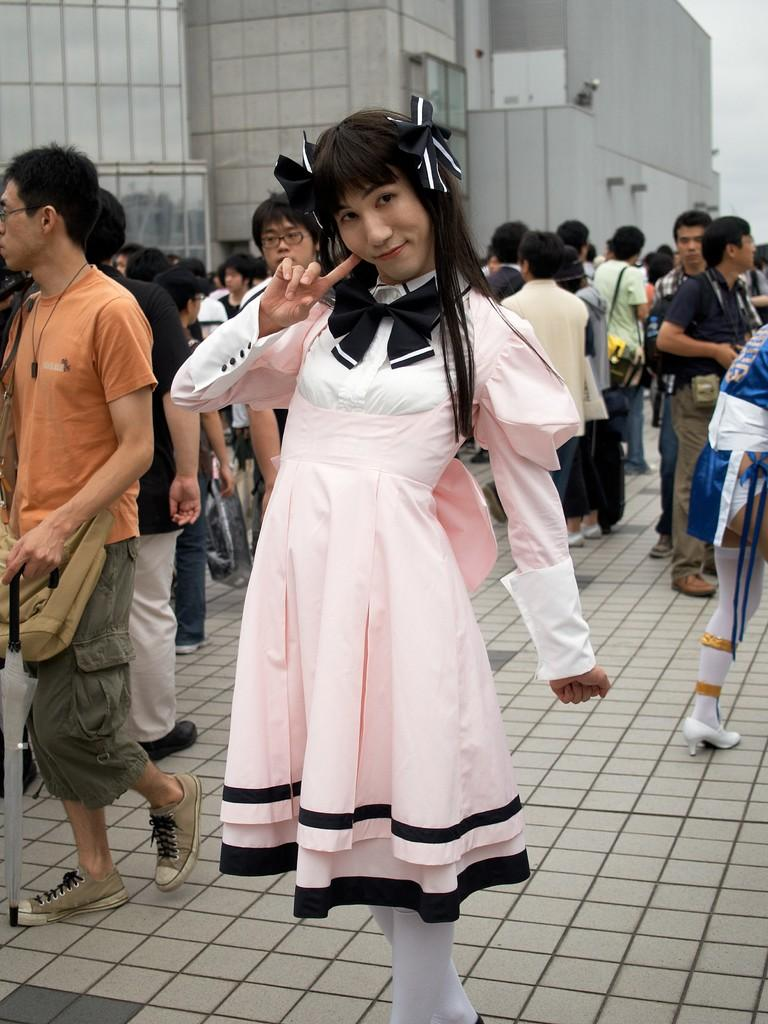How many people are in the image? There are many people in the foreground of the image. What can be seen in the background of the image? There are buildings visible in the background of the image. What type of protest is being held by the potatoes in the image? There are no potatoes present in the image, and therefore no protest can be observed. 